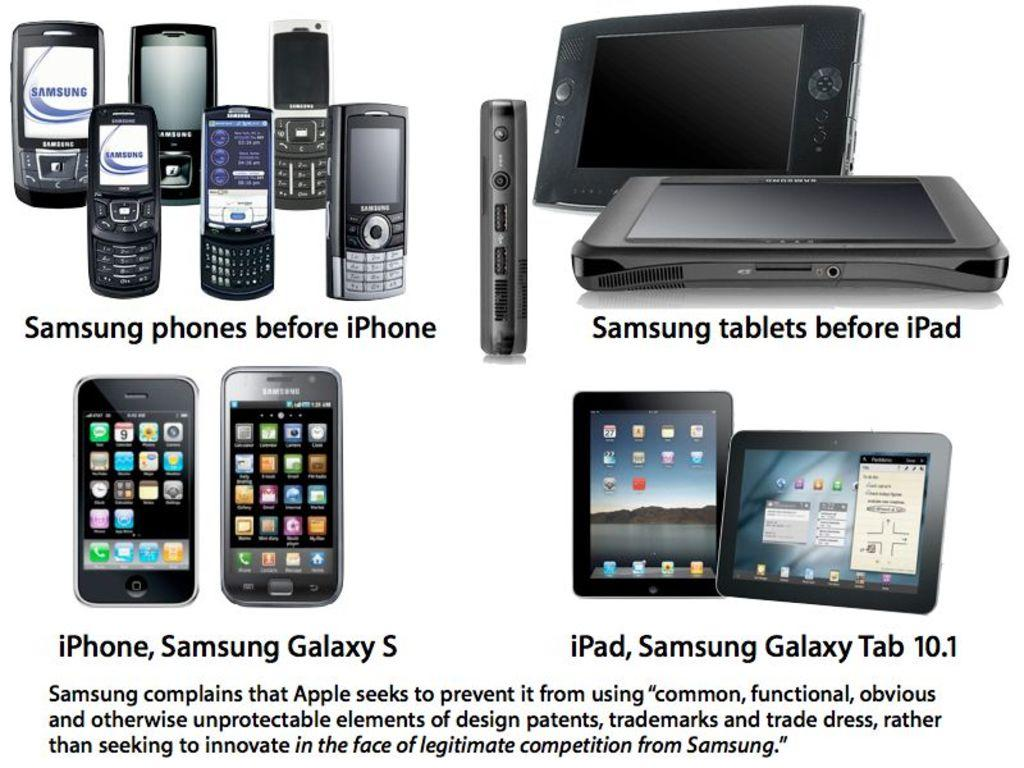<image>
Describe the image concisely. Various Apple and Samsung electronic products are shown above a quote of Samsung complaining about Apple's business tactics. 